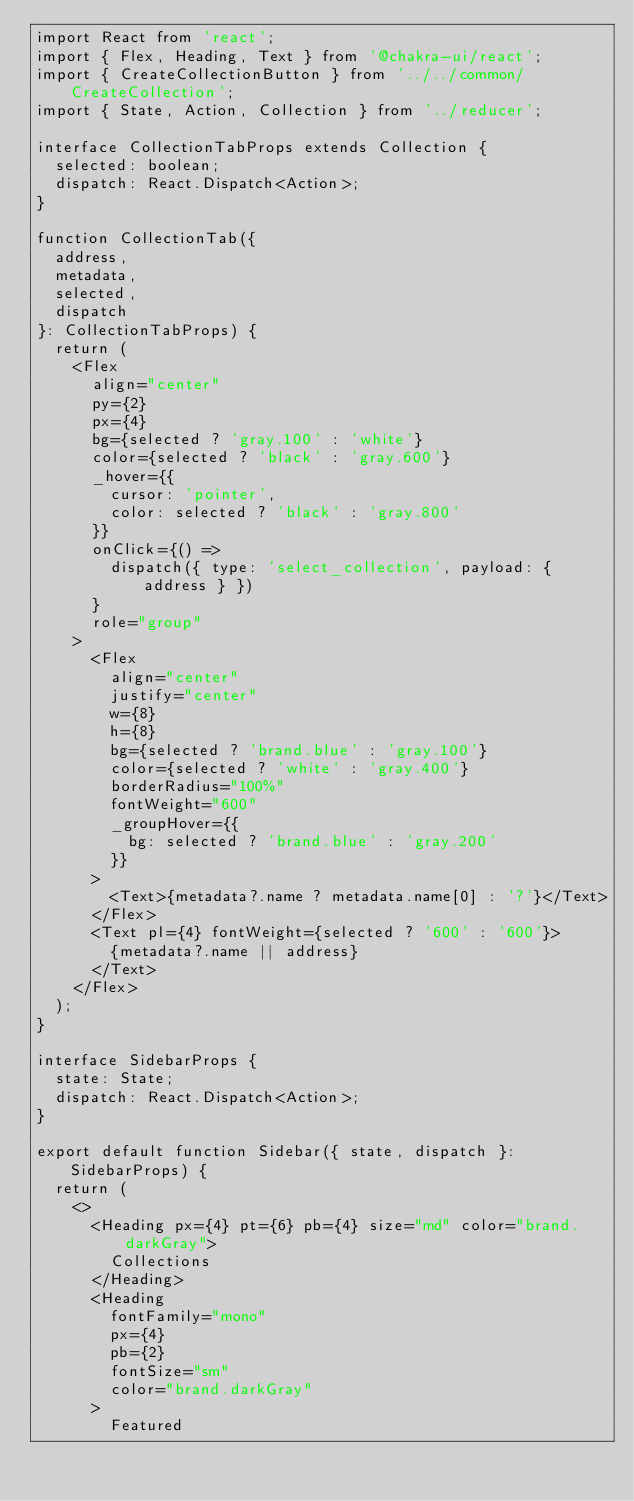<code> <loc_0><loc_0><loc_500><loc_500><_TypeScript_>import React from 'react';
import { Flex, Heading, Text } from '@chakra-ui/react';
import { CreateCollectionButton } from '../../common/CreateCollection';
import { State, Action, Collection } from '../reducer';

interface CollectionTabProps extends Collection {
  selected: boolean;
  dispatch: React.Dispatch<Action>;
}

function CollectionTab({
  address,
  metadata,
  selected,
  dispatch
}: CollectionTabProps) {
  return (
    <Flex
      align="center"
      py={2}
      px={4}
      bg={selected ? 'gray.100' : 'white'}
      color={selected ? 'black' : 'gray.600'}
      _hover={{
        cursor: 'pointer',
        color: selected ? 'black' : 'gray.800'
      }}
      onClick={() =>
        dispatch({ type: 'select_collection', payload: { address } })
      }
      role="group"
    >
      <Flex
        align="center"
        justify="center"
        w={8}
        h={8}
        bg={selected ? 'brand.blue' : 'gray.100'}
        color={selected ? 'white' : 'gray.400'}
        borderRadius="100%"
        fontWeight="600"
        _groupHover={{
          bg: selected ? 'brand.blue' : 'gray.200'
        }}
      >
        <Text>{metadata?.name ? metadata.name[0] : '?'}</Text>
      </Flex>
      <Text pl={4} fontWeight={selected ? '600' : '600'}>
        {metadata?.name || address}
      </Text>
    </Flex>
  );
}

interface SidebarProps {
  state: State;
  dispatch: React.Dispatch<Action>;
}

export default function Sidebar({ state, dispatch }: SidebarProps) {
  return (
    <>
      <Heading px={4} pt={6} pb={4} size="md" color="brand.darkGray">
        Collections
      </Heading>
      <Heading
        fontFamily="mono"
        px={4}
        pb={2}
        fontSize="sm"
        color="brand.darkGray"
      >
        Featured</code> 